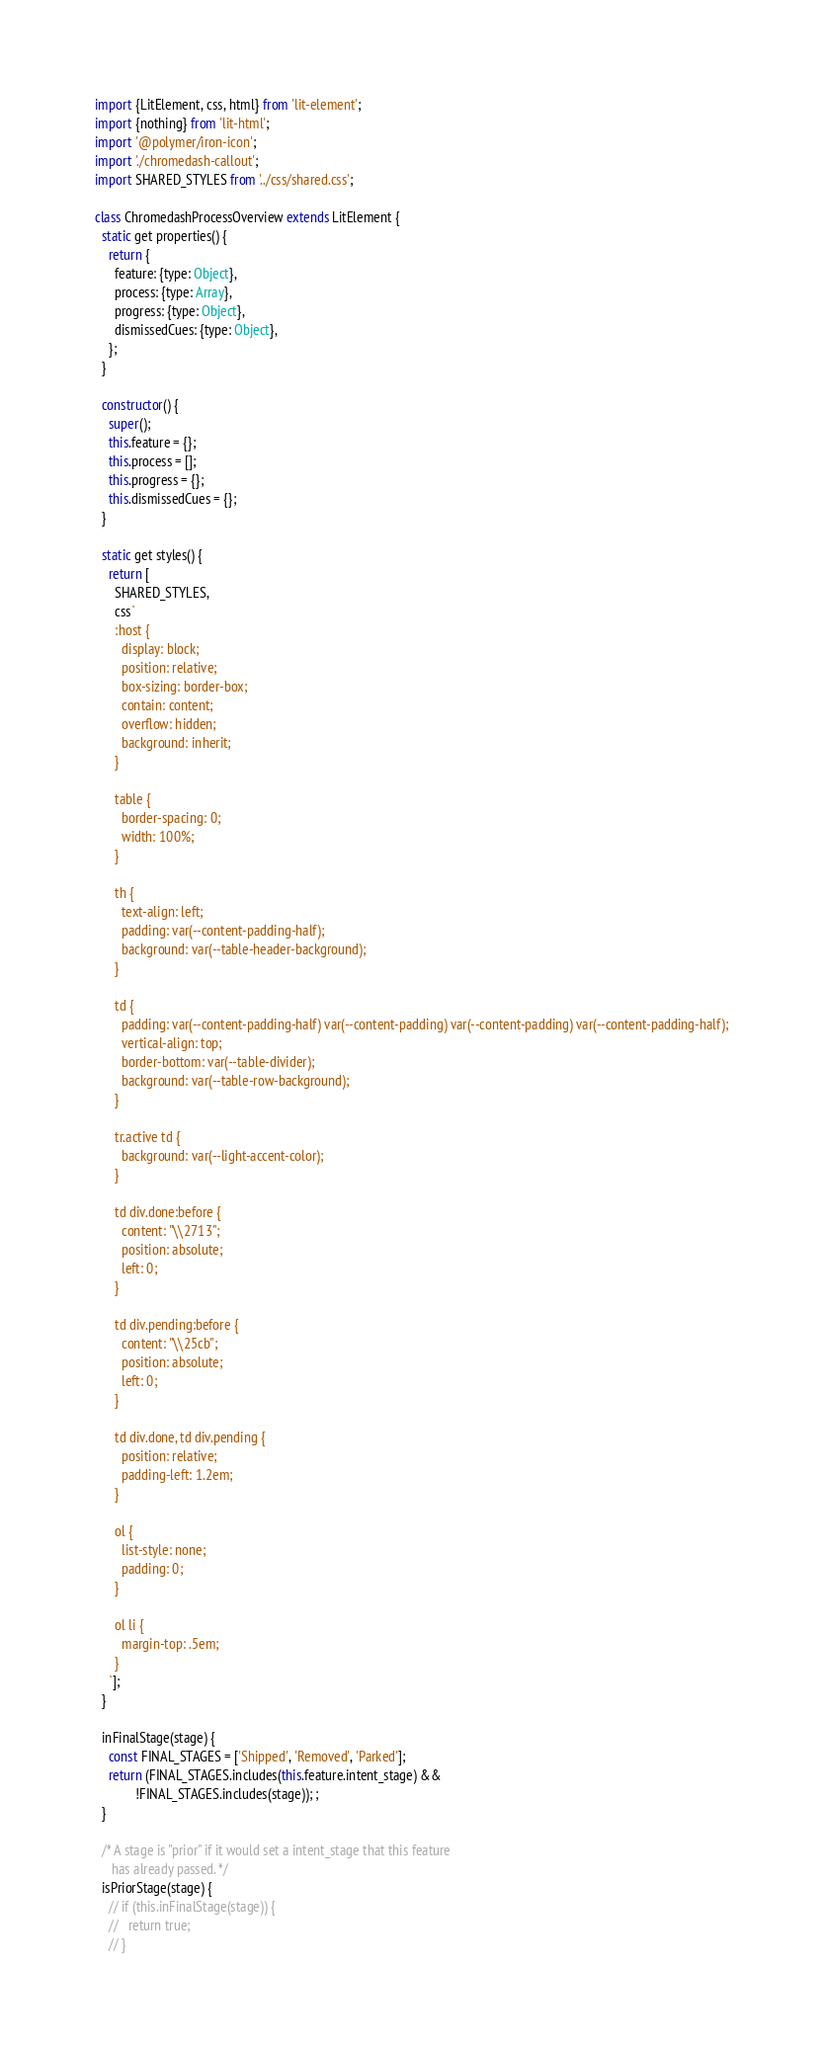Convert code to text. <code><loc_0><loc_0><loc_500><loc_500><_JavaScript_>import {LitElement, css, html} from 'lit-element';
import {nothing} from 'lit-html';
import '@polymer/iron-icon';
import './chromedash-callout';
import SHARED_STYLES from '../css/shared.css';

class ChromedashProcessOverview extends LitElement {
  static get properties() {
    return {
      feature: {type: Object},
      process: {type: Array},
      progress: {type: Object},
      dismissedCues: {type: Object},
    };
  }

  constructor() {
    super();
    this.feature = {};
    this.process = [];
    this.progress = {};
    this.dismissedCues = {};
  }

  static get styles() {
    return [
      SHARED_STYLES,
      css`
      :host {
        display: block;
        position: relative;
        box-sizing: border-box;
        contain: content;
        overflow: hidden;
        background: inherit;
      }

      table {
        border-spacing: 0;
        width: 100%;
      }

      th {
        text-align: left;
        padding: var(--content-padding-half);
        background: var(--table-header-background);
      }

      td {
        padding: var(--content-padding-half) var(--content-padding) var(--content-padding) var(--content-padding-half);
        vertical-align: top;
        border-bottom: var(--table-divider);
        background: var(--table-row-background);
      }

      tr.active td {
        background: var(--light-accent-color);
      }

      td div.done:before {
        content: "\\2713";
        position: absolute;
        left: 0;
      }

      td div.pending:before {
        content: "\\25cb";
        position: absolute;
        left: 0;
      }

      td div.done, td div.pending {
        position: relative;
        padding-left: 1.2em;
      }

      ol {
        list-style: none;
        padding: 0;
      }

      ol li {
        margin-top: .5em;
      }
    `];
  }

  inFinalStage(stage) {
    const FINAL_STAGES = ['Shipped', 'Removed', 'Parked'];
    return (FINAL_STAGES.includes(this.feature.intent_stage) &&
            !FINAL_STAGES.includes(stage)); ;
  }

  /* A stage is "prior" if it would set a intent_stage that this feature
     has already passed. */
  isPriorStage(stage) {
    // if (this.inFinalStage(stage)) {
    //   return true;
    // }</code> 